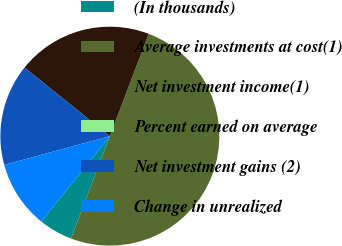Convert chart to OTSL. <chart><loc_0><loc_0><loc_500><loc_500><pie_chart><fcel>(In thousands)<fcel>Average investments at cost(1)<fcel>Net investment income(1)<fcel>Percent earned on average<fcel>Net investment gains (2)<fcel>Change in unrealized<nl><fcel>5.0%<fcel>50.0%<fcel>20.0%<fcel>0.0%<fcel>15.0%<fcel>10.0%<nl></chart> 